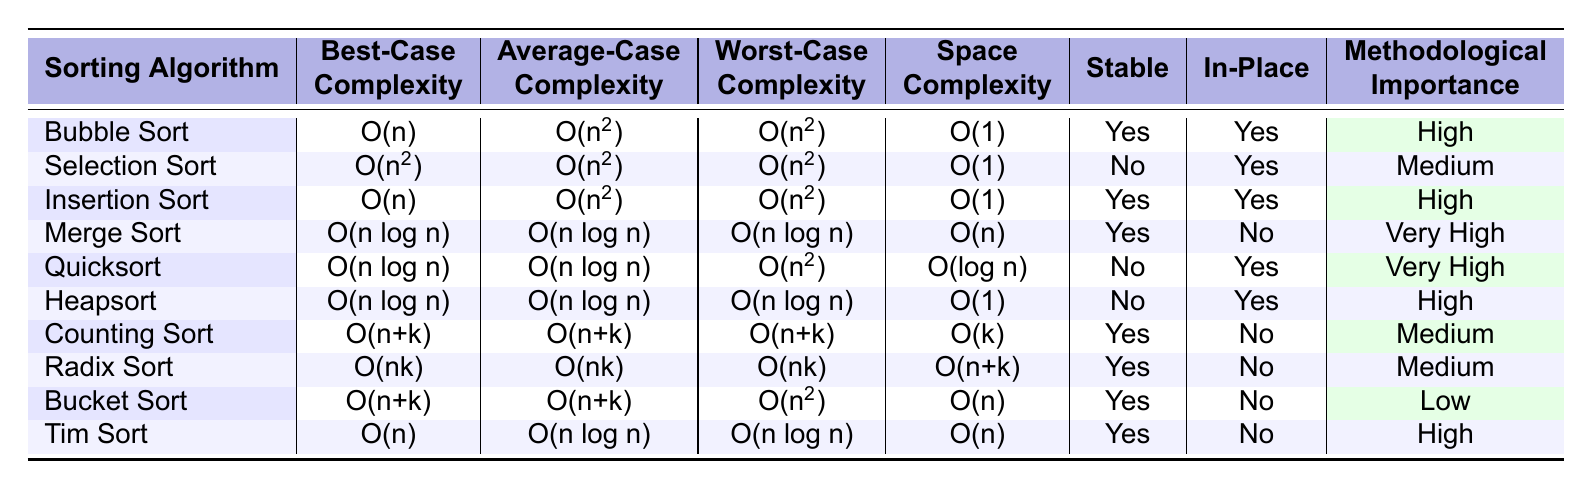What is the space complexity of Merge Sort? From the table, the space complexity for Merge Sort is specified in the "Space Complexity" column, which indicates that it requires O(n) space.
Answer: O(n) Which sorting algorithm has a worst-case complexity of O(n^2)? The table lists the worst-case complexities of various sorting algorithms. Upon review, Bubble Sort, Selection Sort, and Bucket Sort each have a worst-case complexity of O(n^2).
Answer: Bubble Sort, Selection Sort, Bucket Sort Is Insertion Sort a stable sorting algorithm? The "Stable" column in the table shows "Yes" for Insertion Sort, which means it is stable.
Answer: Yes What is the average-case complexity of Counting Sort? Looking at the "Average-Case Complexity" column for Counting Sort, it is listed as O(n+k).
Answer: O(n+k) How many sorting algorithms have a space complexity of O(1)? Review the "Space Complexity" column and count the algorithms that have O(1) listed as their space complexity. These algorithms are Bubble Sort, Selection Sort, Heapsort, and Quicksort, totaling four algorithms.
Answer: 4 Which sorting algorithm has the highest methodological importance? The table lists Methodological Importance for various algorithms. Merge Sort has the highest designation, labeled as "Very High".
Answer: Merge Sort What is the difference between the best-case complexity of Quick Sort and Insertion Sort? The best-case complexities for Quick Sort and Insertion Sort, as per the table, are O(n log n) and O(n), respectively. Subtracting O(n) from O(n log n) will give us O(n log n - n).
Answer: O(n log n - n) Which sorting algorithms are stable and have a worst-case complexity of O(n log n)? From the table, the sorting algorithms that are stable and have a worst-case complexity of O(n log n) are Merge Sort and Tim Sort.
Answer: Merge Sort, Tim Sort If an algorithm is not in-place, is it also likely to have a higher space complexity? By examining the table, both Merge Sort and Counting Sort lack in-place characteristics, and they show different space complexities. Specifically, Merge Sort requires O(n) space, while Counting Sort requires O(k). Therefore, while many non-in-place algorithms do have higher space complexities, it is not always guaranteed.
Answer: Not always Identify the algorithm with the lowest methodological importance and explain its characteristics regarding stability and space complexity. The algorithm with the lowest methodological importance in the table is Bucket Sort, which is not stable (No) and has a space complexity of O(n).
Answer: Bucket Sort, not stable, O(n) space complexity 